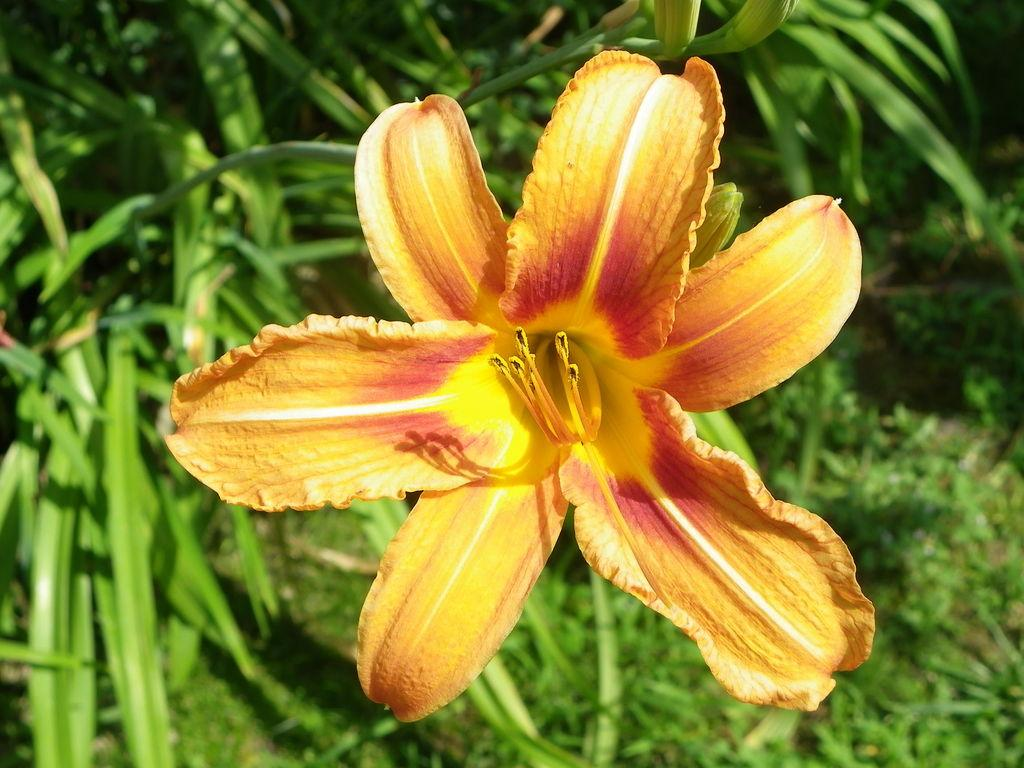What is the main subject of the picture? The main subject of the picture is a yellow flower. Where is the yellow flower located in the picture? The yellow flower is in the middle of the picture. What else can be seen in the background of the picture? There are plants in the background of the picture. Who is the owner of the ship in the picture? There is no ship present in the picture; it features a yellow flower and plants in the background. 